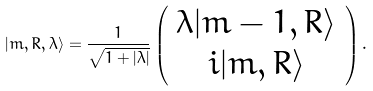Convert formula to latex. <formula><loc_0><loc_0><loc_500><loc_500>| m , { R } , \lambda \rangle = \frac { 1 } { \sqrt { 1 + | \lambda | } } \left ( \begin{array} { c } \lambda | m - 1 , { R } \rangle \\ i | m , { R } \rangle \end{array} \right ) .</formula> 